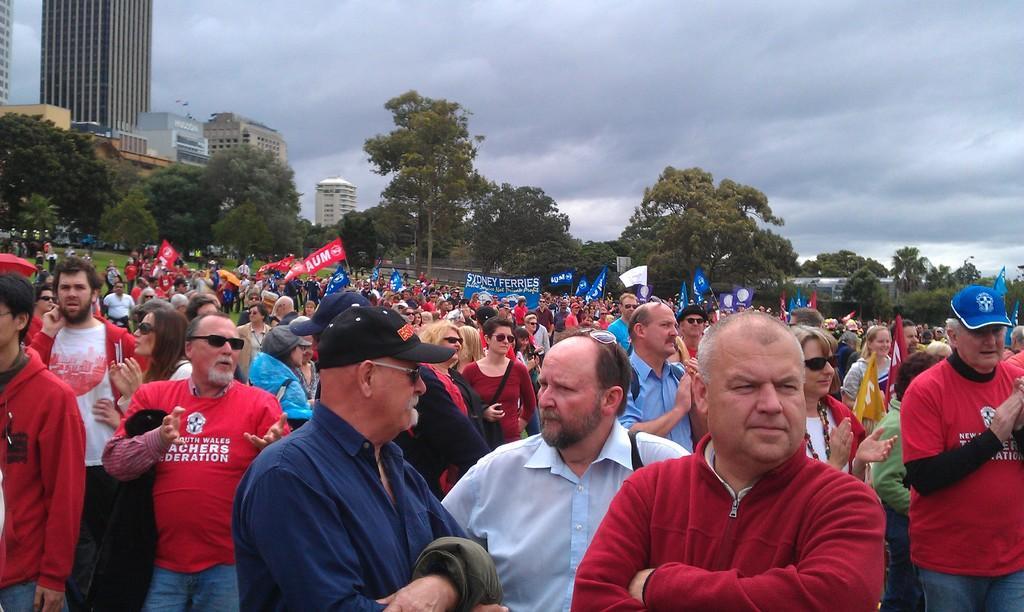How would you summarize this image in a sentence or two? In this picture we can see a group of people and in the background we can see banners, flags, buildings, trees and the sky. 